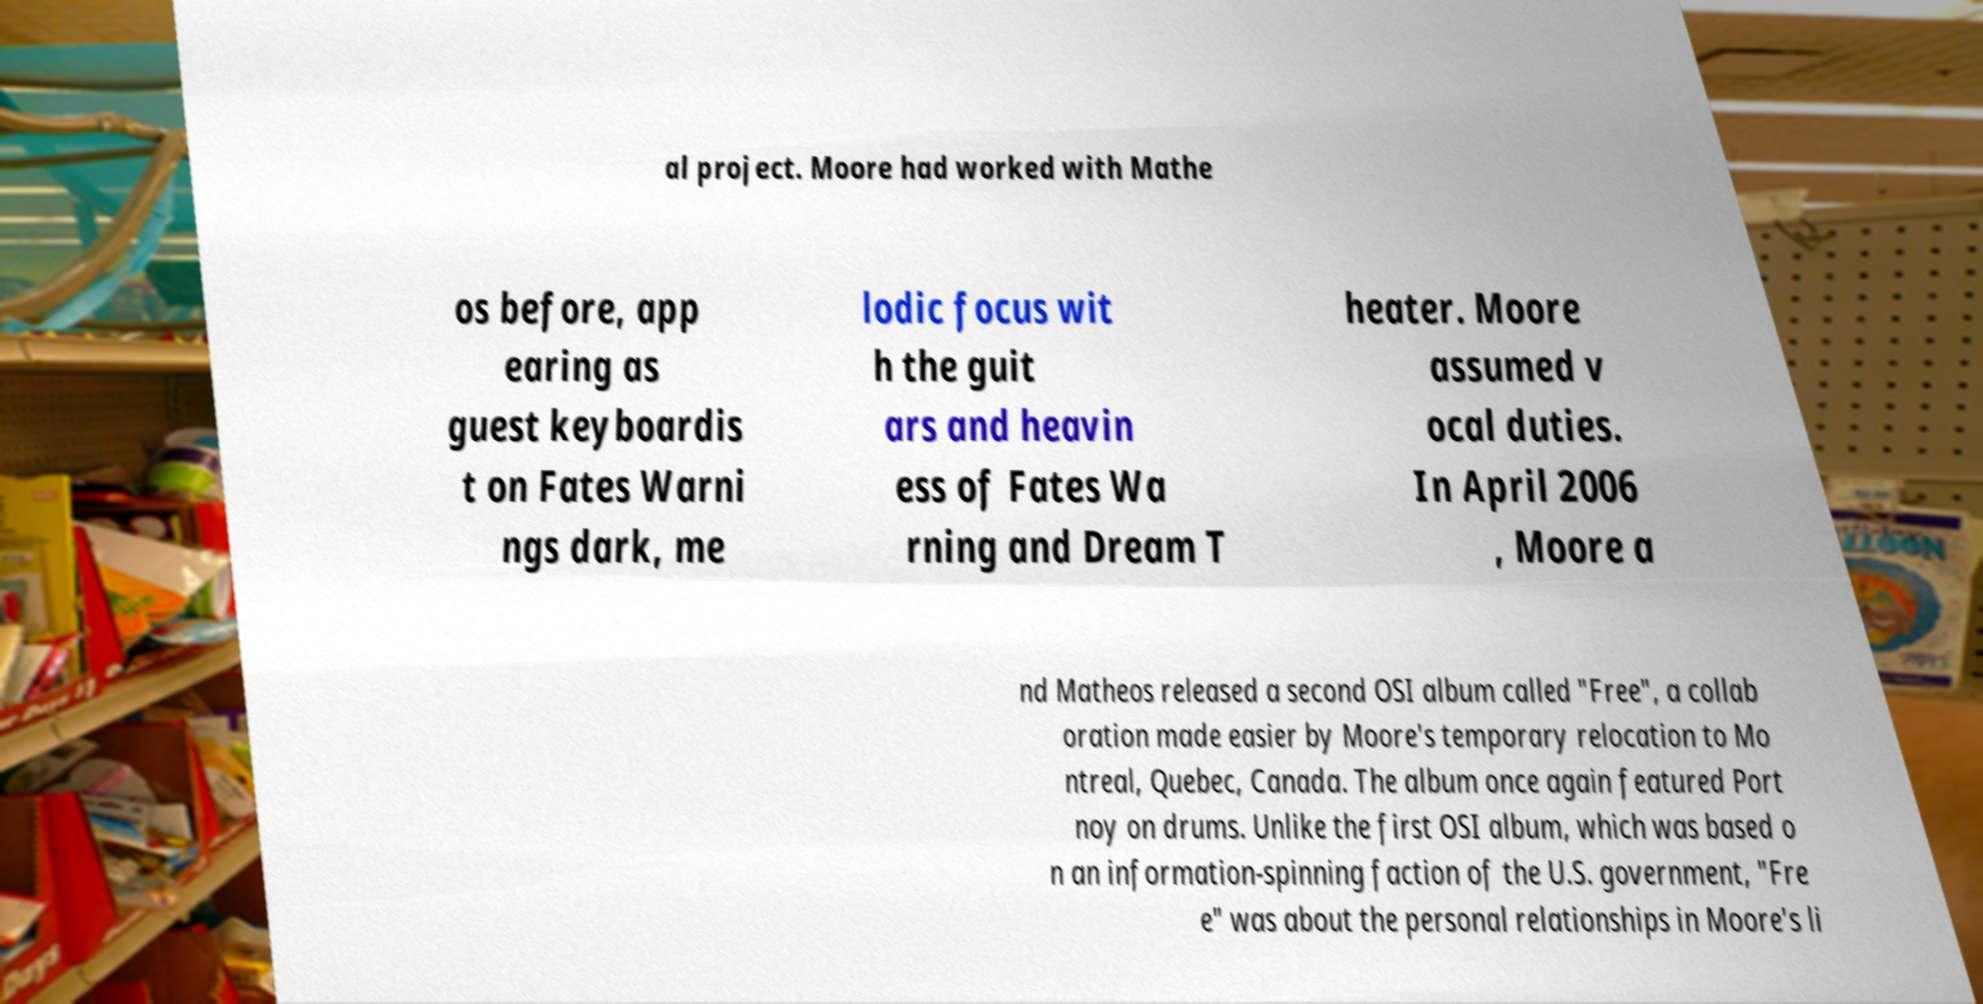I need the written content from this picture converted into text. Can you do that? al project. Moore had worked with Mathe os before, app earing as guest keyboardis t on Fates Warni ngs dark, me lodic focus wit h the guit ars and heavin ess of Fates Wa rning and Dream T heater. Moore assumed v ocal duties. In April 2006 , Moore a nd Matheos released a second OSI album called "Free", a collab oration made easier by Moore's temporary relocation to Mo ntreal, Quebec, Canada. The album once again featured Port noy on drums. Unlike the first OSI album, which was based o n an information-spinning faction of the U.S. government, "Fre e" was about the personal relationships in Moore's li 